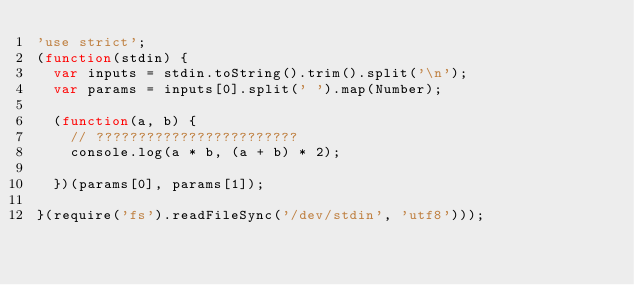Convert code to text. <code><loc_0><loc_0><loc_500><loc_500><_JavaScript_>'use strict';
(function(stdin) {
  var inputs = stdin.toString().trim().split('\n');
  var params = inputs[0].split(' ').map(Number);

  (function(a, b) {
    // ????????????????????????
    console.log(a * b, (a + b) * 2);

  })(params[0], params[1]);

}(require('fs').readFileSync('/dev/stdin', 'utf8')));</code> 